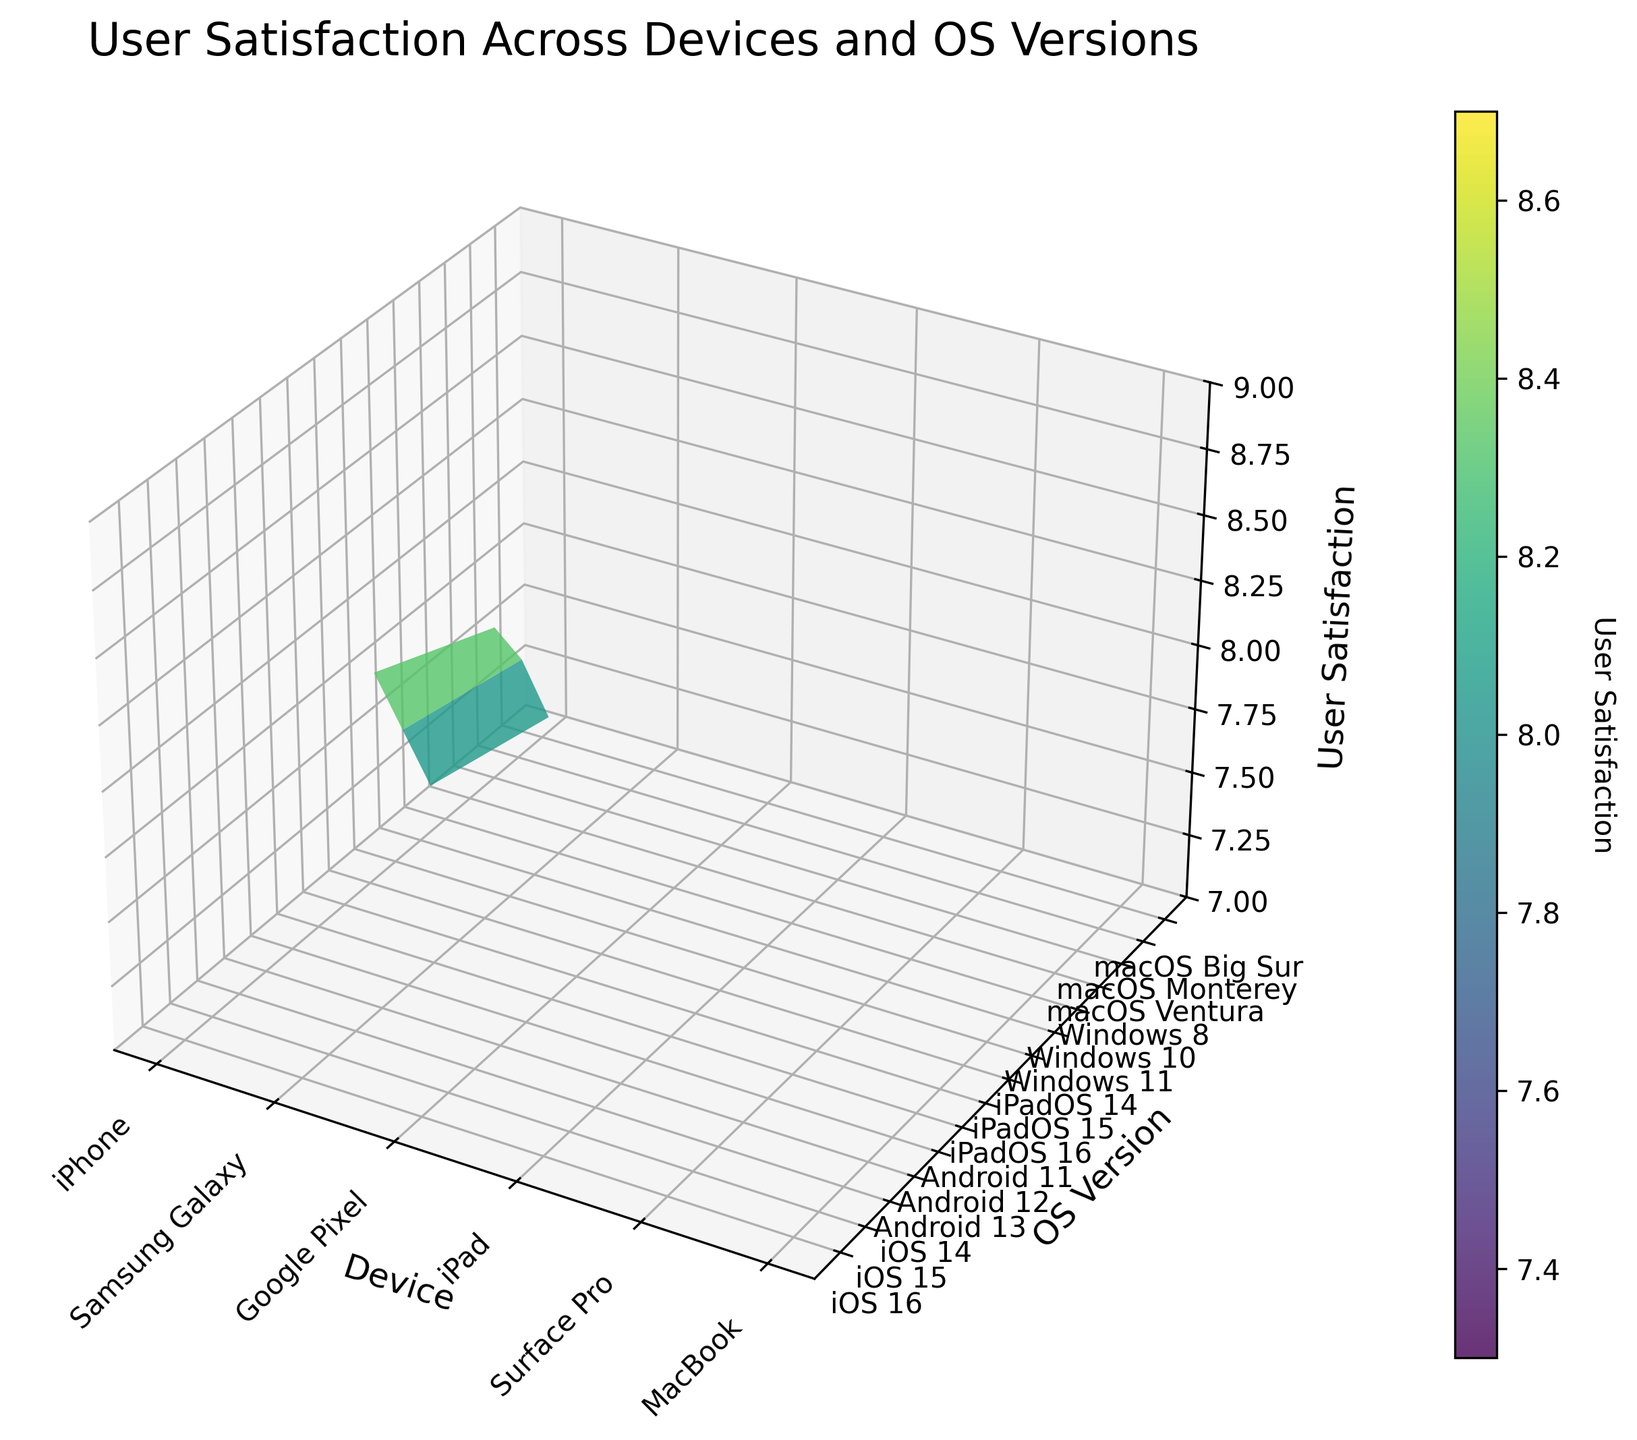What is the highest user satisfaction score across all devices and OS versions? To find the highest user satisfaction score, look at the peak value on the surface plot. The highest point in the Z-axis indicates the maximum satisfaction score.
Answer: 8.8 Which device has the highest user satisfaction on average? To determine the device with the highest average satisfaction, visually inspect the surface plot to determine which device has generally higher Z-values across all OS versions.
Answer: MacBook How does user satisfaction for the iPhone change across different iOS versions? Observe the three corresponding points on the surface plot for iPhone at each iOS version. Check if the satisfaction score increases or decreases as the OS version changes.
Answer: It decreases from iOS 16 to iOS 14 Which OS version shows the lowest average user satisfaction across devices? For each OS version, visually average the Z-values across different devices. Find which OS version has the lowest overall pattern.
Answer: OS versions older than others, e.g., Windows 8 What is the user satisfaction difference between Google Pixel with Android 13 and Android 11? Locate the Z-values for Google Pixel at Android 13 and Android 11. Subtract the Android 11 score from the Android 13 score to find the difference.
Answer: 0.5 Does the user satisfaction for iPads show an overall increase or decrease in newer iPadOS versions? Examine the surface plot's Z-values for iPads across different iPadOS versions. Notice the trend whether the satisfaction score increases, decreases, or remains constant as the iPadOS version becomes newer.
Answer: Increase Which device-OS combination has a satisfaction score closest to 8.0? Inspect the surface plot to find the point where the Z-value is nearest to 8.0. Check for each combination to find the closest match.
Answer: Samsung Galaxy, Android 12 Are there any devices with a satisfaction score below 7.5? Look at the Z-axis values on the surface plot to see if any values fall below the threshold of 7.5. Identify the corresponding device and operating system version.
Answer: Surface Pro, Windows 8 Which device type shows the most consistent user satisfaction across its own OS updates? Determine which device has the least variation in the height of its Z-values across different OS versions. Consistent user satisfaction means more closely clustered points in the Z-axis direction for that device.
Answer: MacBook 